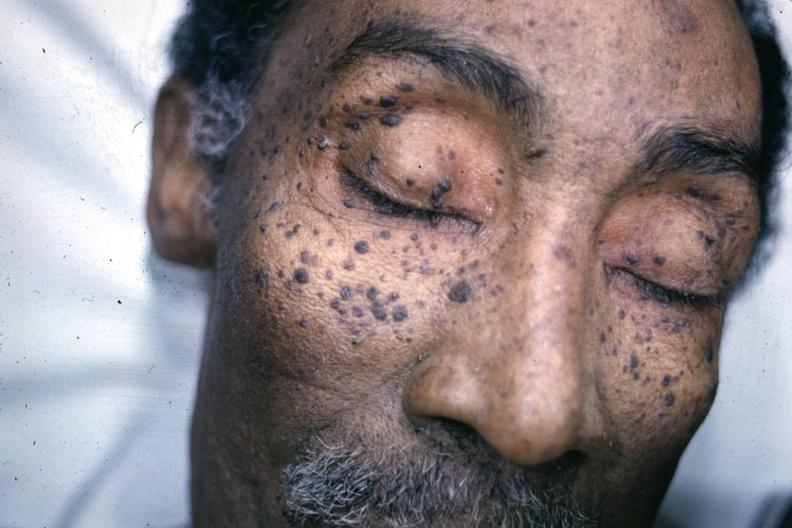s 7182 and 7183 present?
Answer the question using a single word or phrase. No 